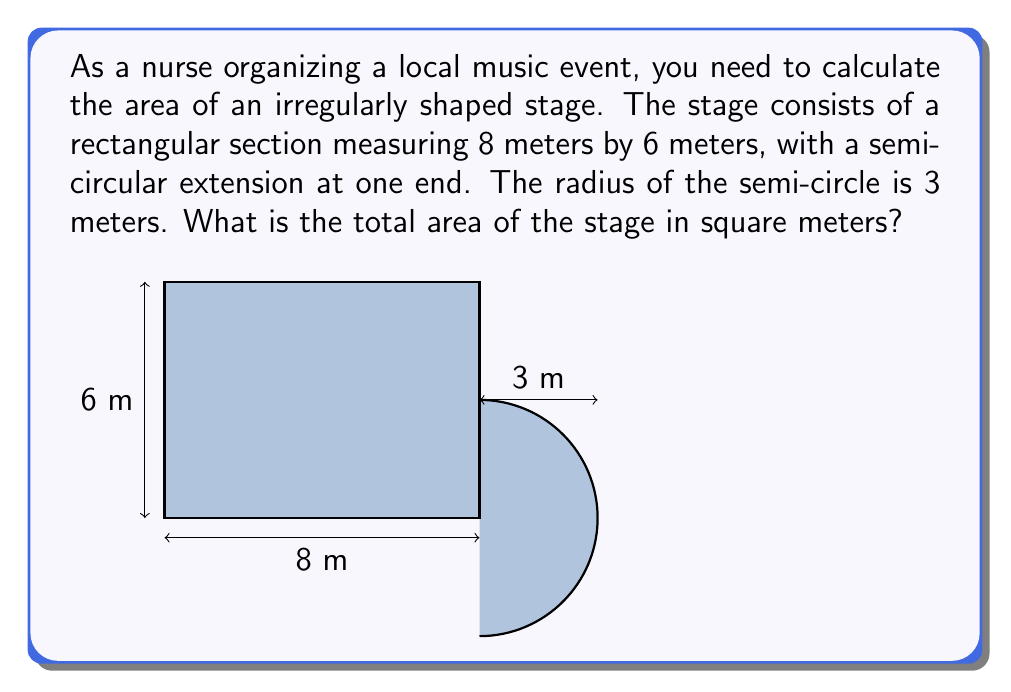Help me with this question. To calculate the total area of the stage, we need to add the areas of the rectangular section and the semi-circular extension.

1. Area of the rectangular section:
   $A_r = l \times w$
   $A_r = 8 \text{ m} \times 6 \text{ m} = 48 \text{ m}^2$

2. Area of the semi-circular extension:
   The area of a full circle is $\pi r^2$, so the area of a semi-circle is half of that.
   $A_s = \frac{1}{2} \pi r^2$
   $A_s = \frac{1}{2} \times \pi \times (3 \text{ m})^2$
   $A_s = \frac{9\pi}{2} \text{ m}^2$

3. Total area of the stage:
   $A_{\text{total}} = A_r + A_s$
   $A_{\text{total}} = 48 \text{ m}^2 + \frac{9\pi}{2} \text{ m}^2$
   $A_{\text{total}} = 48 + \frac{9\pi}{2} \text{ m}^2$

4. Simplifying the expression:
   $A_{\text{total}} = 48 + 4.5\pi \text{ m}^2$
   $A_{\text{total}} \approx 62.12 \text{ m}^2$ (rounded to two decimal places)

Therefore, the total area of the stage is approximately 62.12 square meters.
Answer: $48 + 4.5\pi \text{ m}^2$ or approximately $62.12 \text{ m}^2$ 